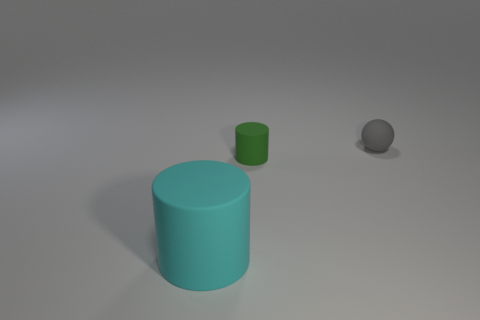Add 2 large matte objects. How many objects exist? 5 Subtract all balls. How many objects are left? 2 Add 2 rubber things. How many rubber things are left? 5 Add 2 tiny cylinders. How many tiny cylinders exist? 3 Subtract 0 yellow balls. How many objects are left? 3 Subtract all cylinders. Subtract all big cyan rubber balls. How many objects are left? 1 